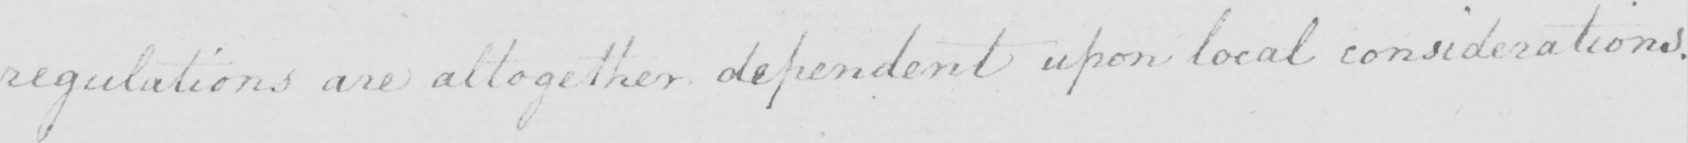Please transcribe the handwritten text in this image. regulations are altogether dependent upon local considerations . 